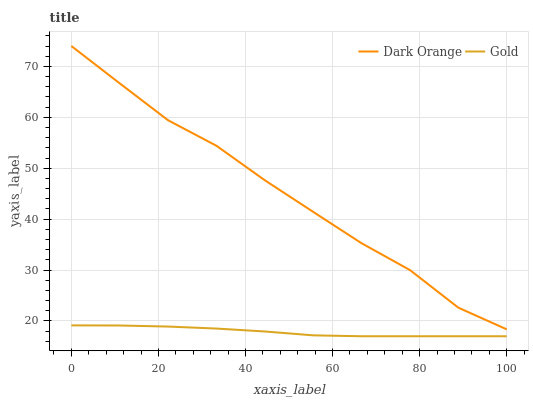Does Gold have the minimum area under the curve?
Answer yes or no. Yes. Does Dark Orange have the maximum area under the curve?
Answer yes or no. Yes. Does Gold have the maximum area under the curve?
Answer yes or no. No. Is Gold the smoothest?
Answer yes or no. Yes. Is Dark Orange the roughest?
Answer yes or no. Yes. Is Gold the roughest?
Answer yes or no. No. Does Gold have the lowest value?
Answer yes or no. Yes. Does Dark Orange have the highest value?
Answer yes or no. Yes. Does Gold have the highest value?
Answer yes or no. No. Is Gold less than Dark Orange?
Answer yes or no. Yes. Is Dark Orange greater than Gold?
Answer yes or no. Yes. Does Gold intersect Dark Orange?
Answer yes or no. No. 